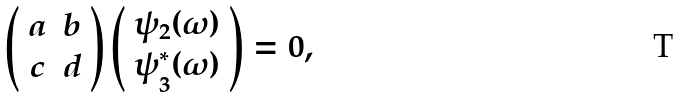<formula> <loc_0><loc_0><loc_500><loc_500>\left ( \begin{array} { c c } a & b \\ c & d \end{array} \right ) \left ( \begin{array} { c } \psi _ { 2 } ( \omega ) \\ \psi _ { 3 } ^ { * } ( \omega ) \end{array} \right ) = 0 ,</formula> 